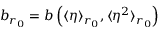<formula> <loc_0><loc_0><loc_500><loc_500>b _ { r _ { 0 } } = b \left ( \langle \eta \rangle _ { r _ { 0 } } , \langle \eta ^ { 2 } \rangle _ { r _ { 0 } } \right )</formula> 